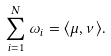<formula> <loc_0><loc_0><loc_500><loc_500>\sum _ { i = 1 } ^ { N } \omega _ { i } = \langle \mu , \nu \rangle .</formula> 